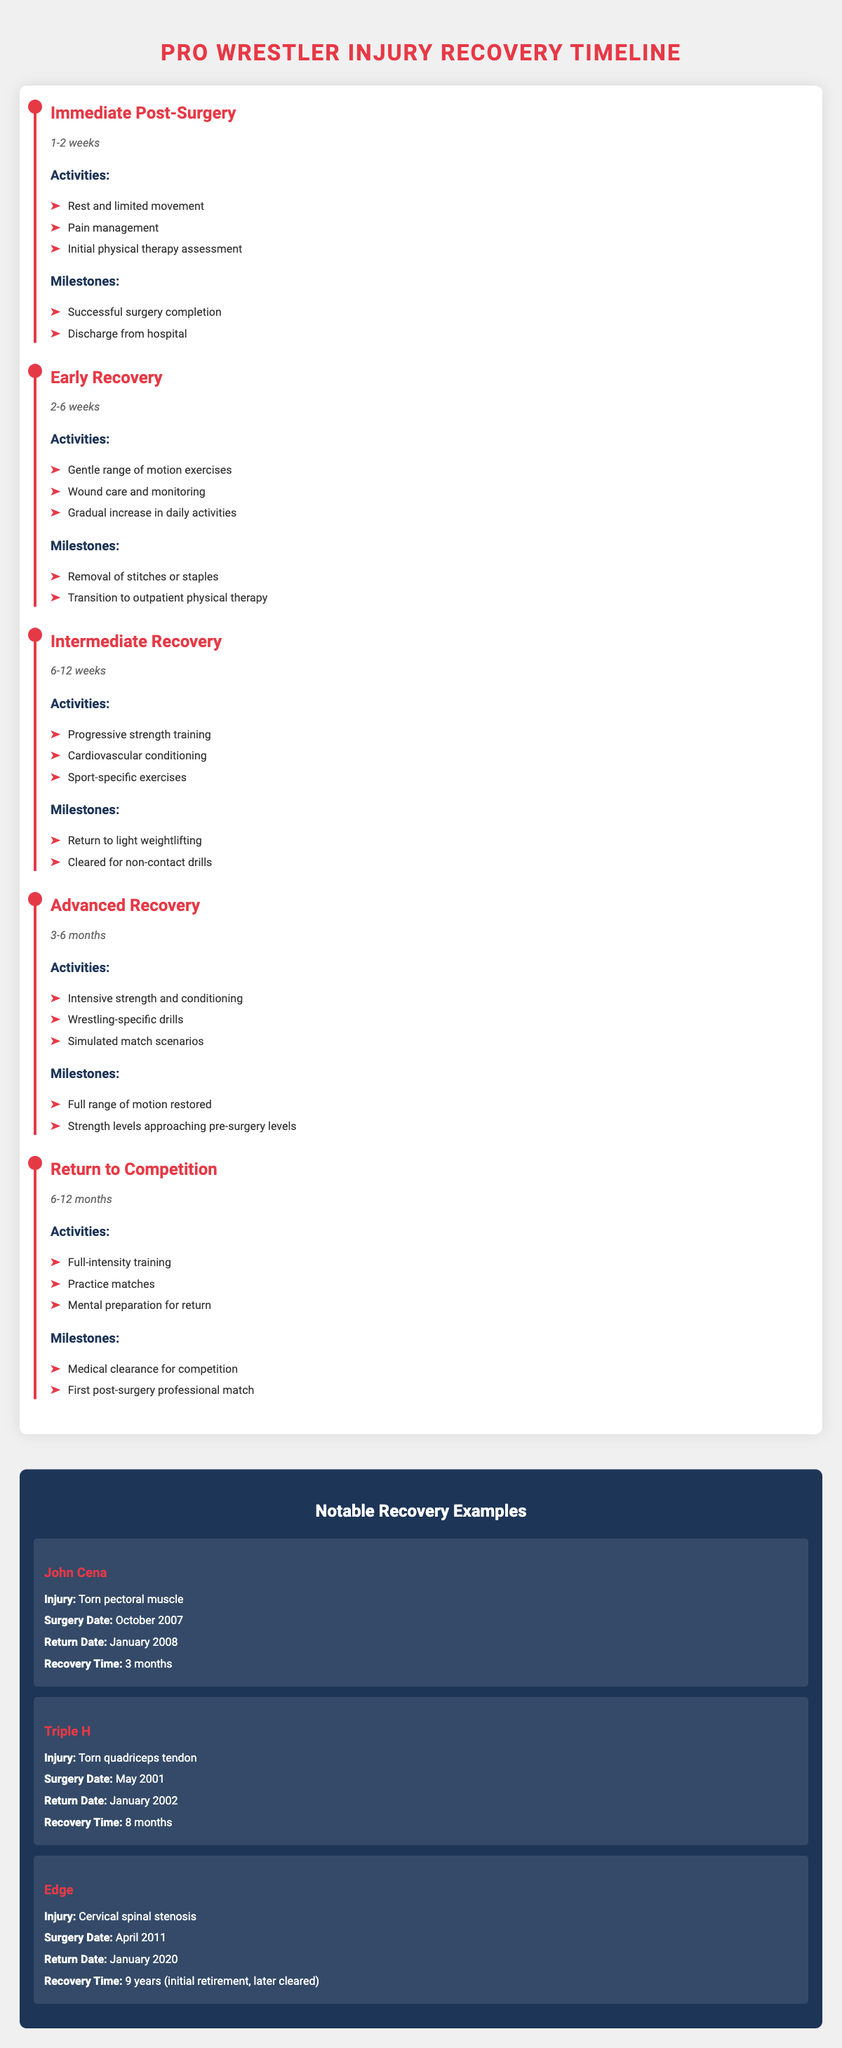What is the duration of the Immediate Post-Surgery phase? The table specifies that the duration of the Immediate Post-Surgery phase is 1-2 weeks.
Answer: 1-2 weeks Which activities are included in the Early Recovery phase? According to the table, the activities in the Early Recovery phase include: Gentle range of motion exercises, Wound care and monitoring, and Gradual increase in daily activities.
Answer: Gentle range of motion exercises, Wound care and monitoring, Gradual increase in daily activities What is the recovery time for John Cena? The data states that John Cena's recovery time after surgery for a torn pectoral muscle was 3 months.
Answer: 3 months Is the duration of Advanced Recovery longer than the Early Recovery phase? The Advanced Recovery phase lasts 3-6 months, while the Early Recovery phase lasts 2-6 weeks. 6 months is longer than 6 weeks.
Answer: Yes What are the milestones reached by the end of the Intermediate Recovery phase? The milestones for the Intermediate Recovery phase are: Return to light weightlifting and Cleared for non-contact drills. Both can be found in the table entry for this phase.
Answer: Return to light weightlifting, Cleared for non-contact drills What is the total duration from surgery to the Return to Competition phase for a wrestler recovering from major surgery? The Return to Competition phase lasts 6-12 months, and if we take the maximum of 12 months and consider this follows after the Advanced Recovery phase of 3-6 months, we sum 12 and 6 to get a total of up to 18 months. Therefore, the total duration ranges from 12 to 18 months after surgery before returning to competition.
Answer: 12-18 months Which wrestler had the longest recovery time and how long did it take? According to the data, Edge had the longest recovery time, which was 9 years after surgery for cervical spinal stenosis. This information is directly referenced in the notable examples section.
Answer: 9 years At the end of which recovery phase is a wrestler typically cleared for non-contact drills? The table specifies that a wrestler is typically cleared for non-contact drills by the end of the Intermediate Recovery phase, where this milestone is listed.
Answer: Intermediate Recovery phase What is the average recovery time of the wrestlers listed in the notable examples? The recovery times in months are: John Cena 3 months, Triple H 8 months, and Edge is considered as having 9 years, which equals 108 months. Adding these gives a total of 119 months, and dividing by 3 wrestlers gives an average of about 39.67 months.
Answer: Approximately 39.67 months 